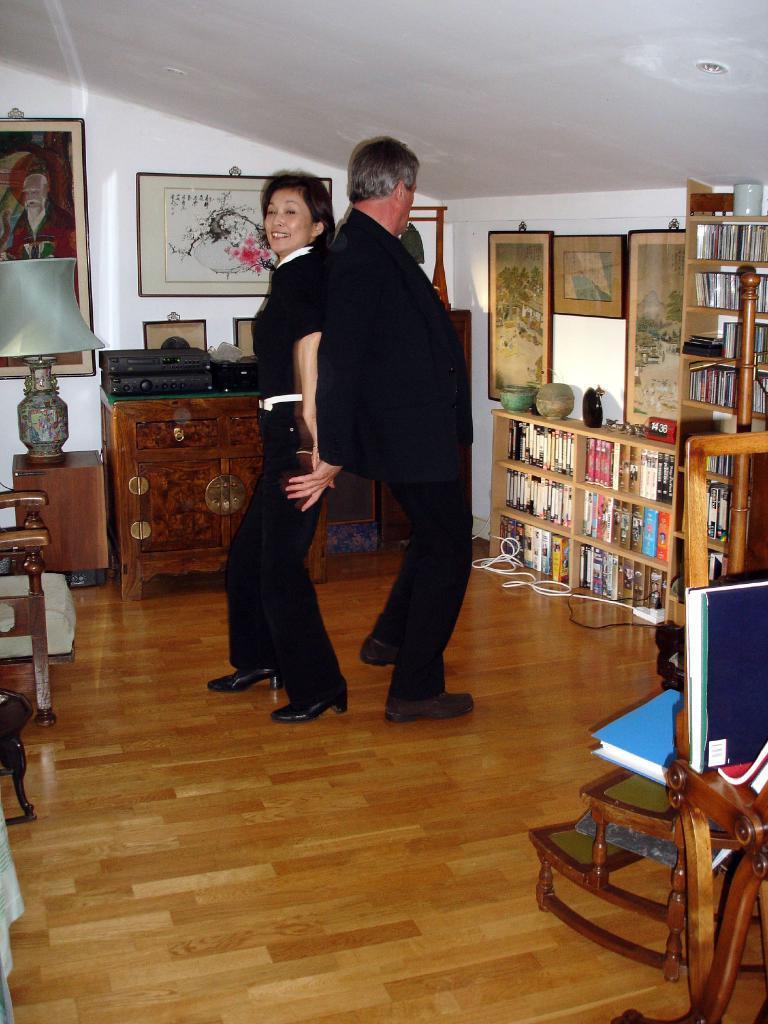How would you summarize this image in a sentence or two? This picture describe about the inside view of the room in which one man and woman is dancing , A man wearing black coat holding the hand of the woman who is wearing black t- shirt and jean. Behind we can see a wooden table and photo frame on the wall. On the right side we can see a wooden rack full of books and table light. Below we can see wooden floor and chair. 